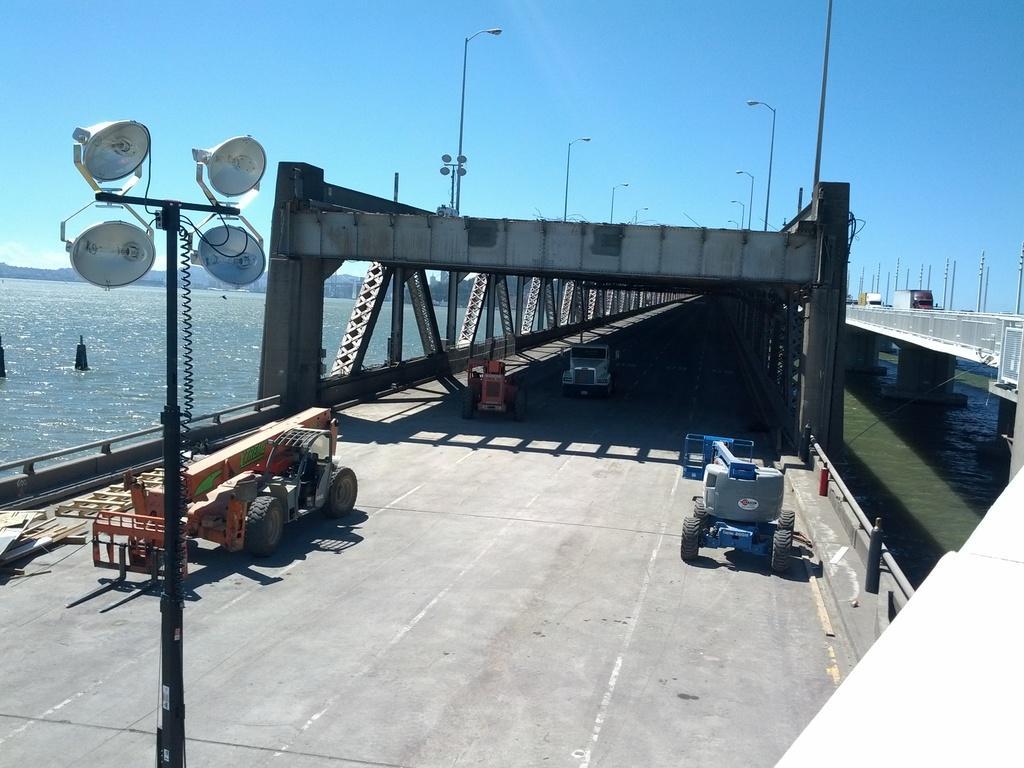Please provide a concise description of this image. In this image we can see few vehicles. There are two bridges in the image. We can see the sky in the image. We can see the sea in the image. There are many lights in the image. We can see few street lights in the image. 